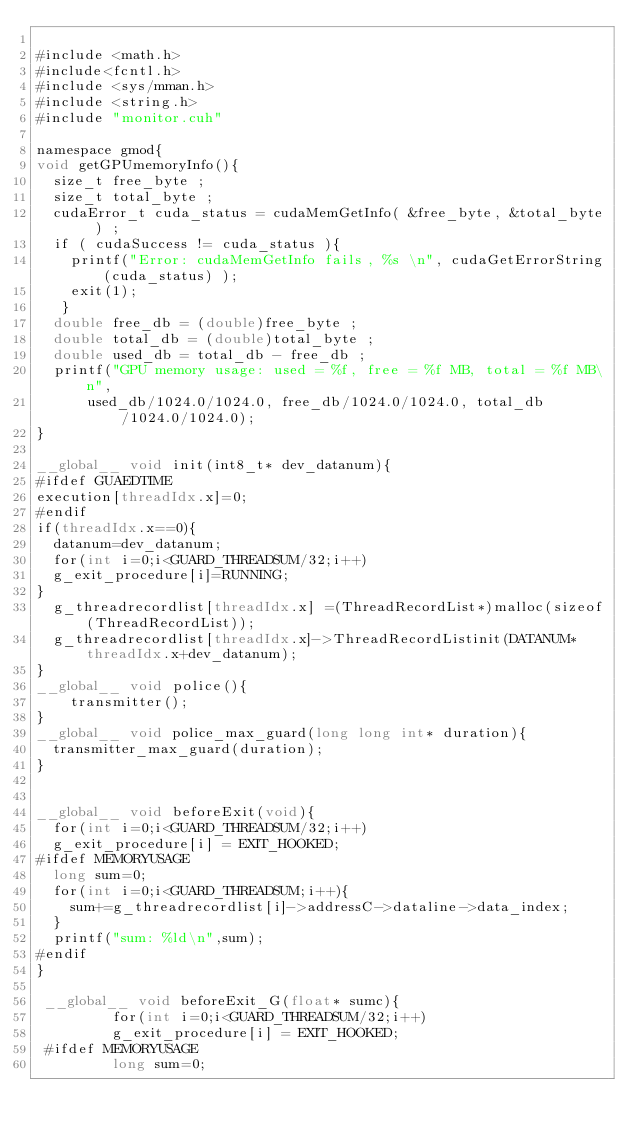Convert code to text. <code><loc_0><loc_0><loc_500><loc_500><_Cuda_>
#include <math.h>
#include<fcntl.h>
#include <sys/mman.h>
#include <string.h>
#include "monitor.cuh"

namespace gmod{
void getGPUmemoryInfo(){
	size_t free_byte ;
	size_t total_byte ;
	cudaError_t cuda_status = cudaMemGetInfo( &free_byte, &total_byte ) ;
	if ( cudaSuccess != cuda_status ){
		printf("Error: cudaMemGetInfo fails, %s \n", cudaGetErrorString(cuda_status) );
		exit(1);
   }
	double free_db = (double)free_byte ;
	double total_db = (double)total_byte ;
	double used_db = total_db - free_db ;
	printf("GPU memory usage: used = %f, free = %f MB, total = %f MB\n",
			used_db/1024.0/1024.0, free_db/1024.0/1024.0, total_db/1024.0/1024.0);
}

__global__ void init(int8_t* dev_datanum){
#ifdef GUAEDTIME
execution[threadIdx.x]=0;
#endif
if(threadIdx.x==0){
	datanum=dev_datanum;
	for(int i=0;i<GUARD_THREADSUM/32;i++)
	g_exit_procedure[i]=RUNNING;
}
	g_threadrecordlist[threadIdx.x] =(ThreadRecordList*)malloc(sizeof(ThreadRecordList));
	g_threadrecordlist[threadIdx.x]->ThreadRecordListinit(DATANUM*threadIdx.x+dev_datanum);
}
__global__ void police(){
		transmitter();
}
__global__ void police_max_guard(long long int* duration){
	transmitter_max_guard(duration);
}


__global__ void beforeExit(void){
	for(int i=0;i<GUARD_THREADSUM/32;i++)
	g_exit_procedure[i] = EXIT_HOOKED;
#ifdef MEMORYUSAGE
	long sum=0;
	for(int i=0;i<GUARD_THREADSUM;i++){
		sum+=g_threadrecordlist[i]->addressC->dataline->data_index;
	}
	printf("sum: %ld\n",sum);
#endif
}

 __global__ void beforeExit_G(float* sumc){
         for(int i=0;i<GUARD_THREADSUM/32;i++)
         g_exit_procedure[i] = EXIT_HOOKED;
 #ifdef MEMORYUSAGE
         long sum=0;</code> 